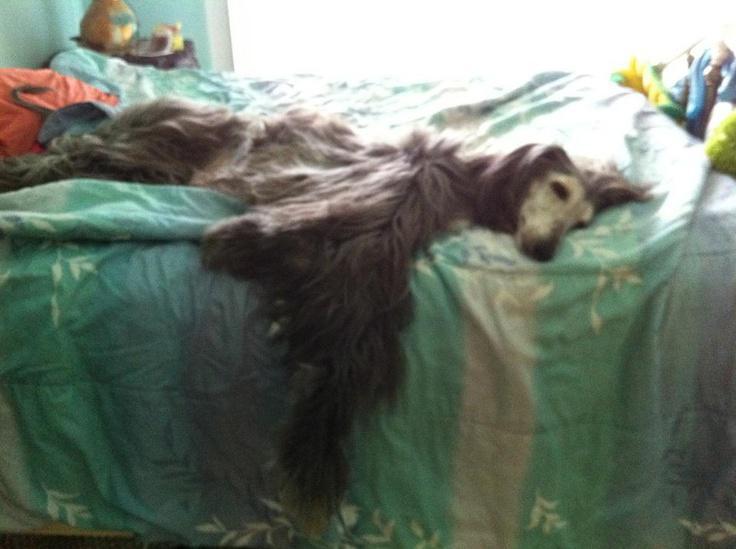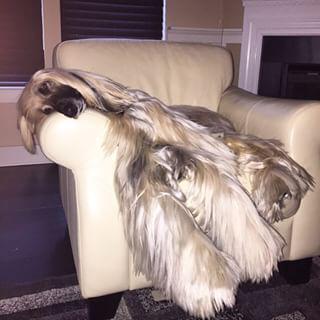The first image is the image on the left, the second image is the image on the right. For the images displayed, is the sentence "In one image, a large light colored dog with very long hair is lounging on the arm of an overstuffed chair inside a home." factually correct? Answer yes or no. Yes. The first image is the image on the left, the second image is the image on the right. Assess this claim about the two images: "An image shows a hound sleeping on a solid-white fabric-covered furniture item.". Correct or not? Answer yes or no. Yes. 